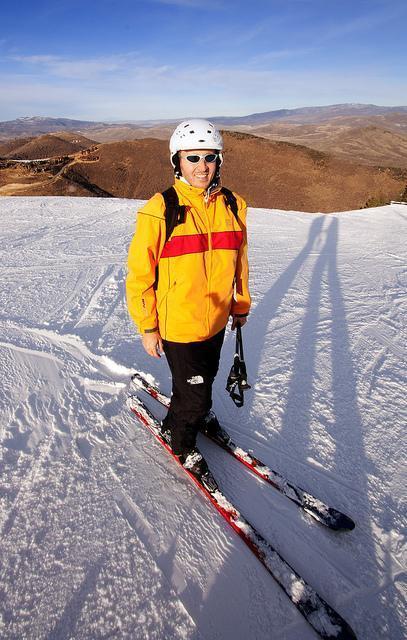How many ski are there?
Give a very brief answer. 1. How many people can be seen?
Give a very brief answer. 1. How many propellers does the airplane have?
Give a very brief answer. 0. 